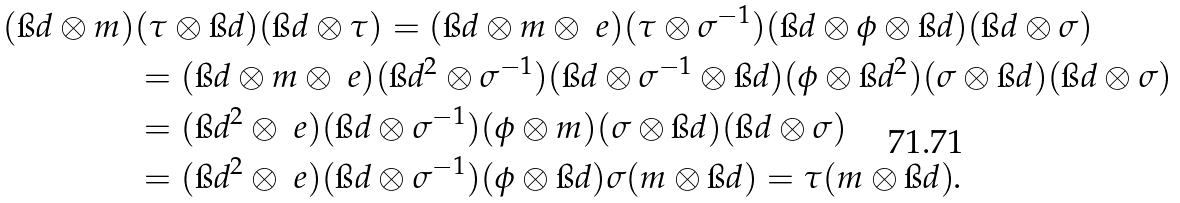Convert formula to latex. <formula><loc_0><loc_0><loc_500><loc_500>( \i d \otimes m ) & ( \tau \otimes \i d ) ( \i d \otimes \tau ) = ( \i d \otimes m \otimes \ e ) ( \tau \otimes \sigma ^ { - 1 } ) ( \i d \otimes \phi \otimes \i d ) ( \i d \otimes \sigma ) \\ & = ( \i d \otimes m \otimes \ e ) ( \i d ^ { 2 } \otimes \sigma ^ { - 1 } ) ( \i d \otimes \sigma ^ { - 1 } \otimes \i d ) ( \phi \otimes \i d ^ { 2 } ) ( \sigma \otimes \i d ) ( \i d \otimes \sigma ) \\ & = ( \i d ^ { 2 } \otimes \ e ) ( \i d \otimes \sigma ^ { - 1 } ) ( \phi \otimes m ) ( \sigma \otimes \i d ) ( \i d \otimes \sigma ) \\ & = ( \i d ^ { 2 } \otimes \ e ) ( \i d \otimes \sigma ^ { - 1 } ) ( \phi \otimes \i d ) \sigma ( m \otimes \i d ) = \tau ( m \otimes \i d ) .</formula> 